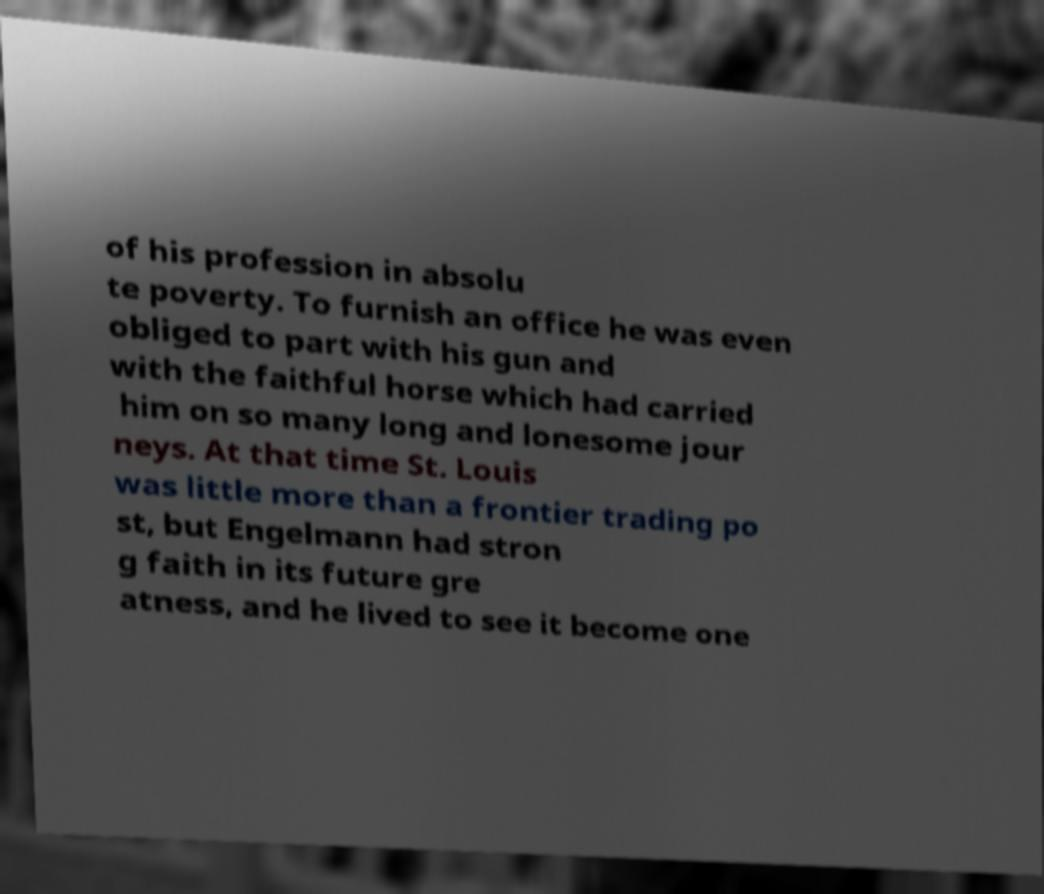Please read and relay the text visible in this image. What does it say? of his profession in absolu te poverty. To furnish an office he was even obliged to part with his gun and with the faithful horse which had carried him on so many long and lonesome jour neys. At that time St. Louis was little more than a frontier trading po st, but Engelmann had stron g faith in its future gre atness, and he lived to see it become one 